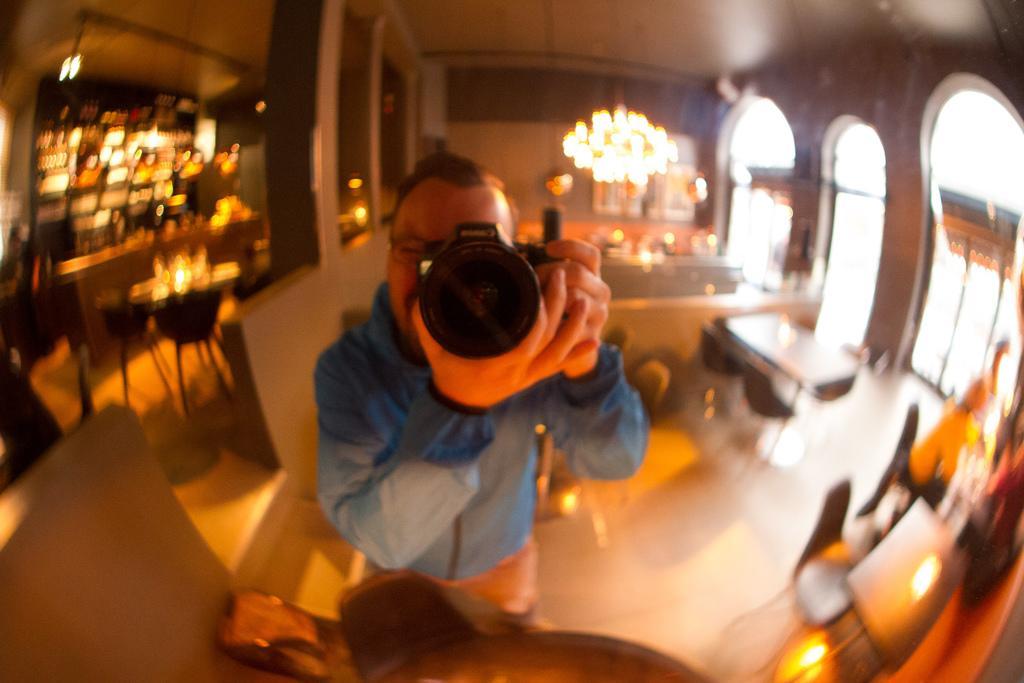Could you give a brief overview of what you see in this image? In this picture we can see a person holding a camera, here we can see a table, chairs, lights, pillars, wall and some objects. 